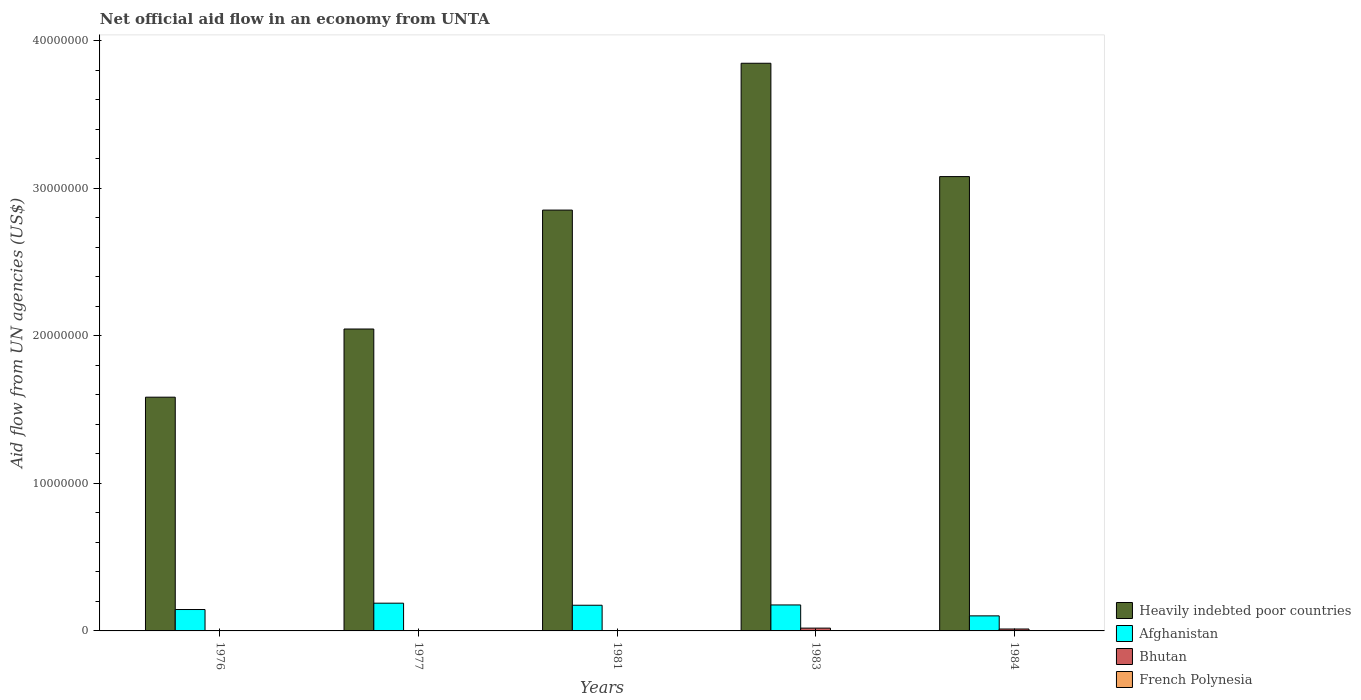How many different coloured bars are there?
Offer a terse response. 4. Are the number of bars per tick equal to the number of legend labels?
Ensure brevity in your answer.  Yes. How many bars are there on the 3rd tick from the left?
Make the answer very short. 4. What is the net official aid flow in Heavily indebted poor countries in 1984?
Your response must be concise. 3.08e+07. Across all years, what is the maximum net official aid flow in Bhutan?
Your response must be concise. 1.90e+05. Across all years, what is the minimum net official aid flow in Heavily indebted poor countries?
Your answer should be very brief. 1.58e+07. In which year was the net official aid flow in Bhutan maximum?
Offer a terse response. 1983. In which year was the net official aid flow in French Polynesia minimum?
Your response must be concise. 1976. What is the total net official aid flow in Afghanistan in the graph?
Offer a very short reply. 7.85e+06. What is the difference between the net official aid flow in Heavily indebted poor countries in 1977 and that in 1984?
Offer a terse response. -1.03e+07. What is the difference between the net official aid flow in Heavily indebted poor countries in 1983 and the net official aid flow in French Polynesia in 1984?
Your response must be concise. 3.84e+07. What is the average net official aid flow in Heavily indebted poor countries per year?
Offer a terse response. 2.68e+07. In the year 1984, what is the difference between the net official aid flow in Afghanistan and net official aid flow in Heavily indebted poor countries?
Ensure brevity in your answer.  -2.98e+07. In how many years, is the net official aid flow in French Polynesia greater than 26000000 US$?
Provide a short and direct response. 0. Is the net official aid flow in Afghanistan in 1981 less than that in 1984?
Make the answer very short. No. What is the difference between the highest and the second highest net official aid flow in Bhutan?
Ensure brevity in your answer.  6.00e+04. In how many years, is the net official aid flow in Heavily indebted poor countries greater than the average net official aid flow in Heavily indebted poor countries taken over all years?
Provide a short and direct response. 3. Is it the case that in every year, the sum of the net official aid flow in Bhutan and net official aid flow in Afghanistan is greater than the sum of net official aid flow in French Polynesia and net official aid flow in Heavily indebted poor countries?
Provide a succinct answer. No. What does the 3rd bar from the left in 1981 represents?
Keep it short and to the point. Bhutan. What does the 4th bar from the right in 1981 represents?
Make the answer very short. Heavily indebted poor countries. Is it the case that in every year, the sum of the net official aid flow in Afghanistan and net official aid flow in Bhutan is greater than the net official aid flow in Heavily indebted poor countries?
Make the answer very short. No. How many years are there in the graph?
Your answer should be very brief. 5. Are the values on the major ticks of Y-axis written in scientific E-notation?
Provide a short and direct response. No. What is the title of the graph?
Offer a terse response. Net official aid flow in an economy from UNTA. What is the label or title of the X-axis?
Provide a succinct answer. Years. What is the label or title of the Y-axis?
Your answer should be compact. Aid flow from UN agencies (US$). What is the Aid flow from UN agencies (US$) of Heavily indebted poor countries in 1976?
Your answer should be compact. 1.58e+07. What is the Aid flow from UN agencies (US$) in Afghanistan in 1976?
Ensure brevity in your answer.  1.45e+06. What is the Aid flow from UN agencies (US$) in Bhutan in 1976?
Offer a terse response. 10000. What is the Aid flow from UN agencies (US$) in Heavily indebted poor countries in 1977?
Your response must be concise. 2.05e+07. What is the Aid flow from UN agencies (US$) of Afghanistan in 1977?
Make the answer very short. 1.88e+06. What is the Aid flow from UN agencies (US$) in Bhutan in 1977?
Your response must be concise. 2.00e+04. What is the Aid flow from UN agencies (US$) in Heavily indebted poor countries in 1981?
Ensure brevity in your answer.  2.85e+07. What is the Aid flow from UN agencies (US$) of Afghanistan in 1981?
Your answer should be very brief. 1.74e+06. What is the Aid flow from UN agencies (US$) in Heavily indebted poor countries in 1983?
Offer a terse response. 3.85e+07. What is the Aid flow from UN agencies (US$) of Afghanistan in 1983?
Give a very brief answer. 1.76e+06. What is the Aid flow from UN agencies (US$) in Heavily indebted poor countries in 1984?
Provide a succinct answer. 3.08e+07. What is the Aid flow from UN agencies (US$) in Afghanistan in 1984?
Keep it short and to the point. 1.02e+06. Across all years, what is the maximum Aid flow from UN agencies (US$) of Heavily indebted poor countries?
Provide a short and direct response. 3.85e+07. Across all years, what is the maximum Aid flow from UN agencies (US$) of Afghanistan?
Offer a terse response. 1.88e+06. Across all years, what is the maximum Aid flow from UN agencies (US$) of Bhutan?
Ensure brevity in your answer.  1.90e+05. Across all years, what is the maximum Aid flow from UN agencies (US$) of French Polynesia?
Your response must be concise. 2.00e+04. Across all years, what is the minimum Aid flow from UN agencies (US$) of Heavily indebted poor countries?
Keep it short and to the point. 1.58e+07. Across all years, what is the minimum Aid flow from UN agencies (US$) in Afghanistan?
Keep it short and to the point. 1.02e+06. What is the total Aid flow from UN agencies (US$) in Heavily indebted poor countries in the graph?
Your response must be concise. 1.34e+08. What is the total Aid flow from UN agencies (US$) in Afghanistan in the graph?
Offer a very short reply. 7.85e+06. What is the difference between the Aid flow from UN agencies (US$) of Heavily indebted poor countries in 1976 and that in 1977?
Your answer should be very brief. -4.62e+06. What is the difference between the Aid flow from UN agencies (US$) in Afghanistan in 1976 and that in 1977?
Ensure brevity in your answer.  -4.30e+05. What is the difference between the Aid flow from UN agencies (US$) of Bhutan in 1976 and that in 1977?
Your answer should be compact. -10000. What is the difference between the Aid flow from UN agencies (US$) of French Polynesia in 1976 and that in 1977?
Ensure brevity in your answer.  0. What is the difference between the Aid flow from UN agencies (US$) in Heavily indebted poor countries in 1976 and that in 1981?
Offer a terse response. -1.27e+07. What is the difference between the Aid flow from UN agencies (US$) in Afghanistan in 1976 and that in 1981?
Offer a terse response. -2.90e+05. What is the difference between the Aid flow from UN agencies (US$) of Heavily indebted poor countries in 1976 and that in 1983?
Your response must be concise. -2.26e+07. What is the difference between the Aid flow from UN agencies (US$) in Afghanistan in 1976 and that in 1983?
Keep it short and to the point. -3.10e+05. What is the difference between the Aid flow from UN agencies (US$) in Bhutan in 1976 and that in 1983?
Your answer should be very brief. -1.80e+05. What is the difference between the Aid flow from UN agencies (US$) of Heavily indebted poor countries in 1976 and that in 1984?
Make the answer very short. -1.50e+07. What is the difference between the Aid flow from UN agencies (US$) of Afghanistan in 1976 and that in 1984?
Your answer should be compact. 4.30e+05. What is the difference between the Aid flow from UN agencies (US$) of French Polynesia in 1976 and that in 1984?
Provide a short and direct response. -10000. What is the difference between the Aid flow from UN agencies (US$) in Heavily indebted poor countries in 1977 and that in 1981?
Provide a succinct answer. -8.06e+06. What is the difference between the Aid flow from UN agencies (US$) in Afghanistan in 1977 and that in 1981?
Offer a terse response. 1.40e+05. What is the difference between the Aid flow from UN agencies (US$) of Heavily indebted poor countries in 1977 and that in 1983?
Provide a succinct answer. -1.80e+07. What is the difference between the Aid flow from UN agencies (US$) in Heavily indebted poor countries in 1977 and that in 1984?
Make the answer very short. -1.03e+07. What is the difference between the Aid flow from UN agencies (US$) in Afghanistan in 1977 and that in 1984?
Your response must be concise. 8.60e+05. What is the difference between the Aid flow from UN agencies (US$) of Bhutan in 1977 and that in 1984?
Your answer should be very brief. -1.10e+05. What is the difference between the Aid flow from UN agencies (US$) in French Polynesia in 1977 and that in 1984?
Your answer should be compact. -10000. What is the difference between the Aid flow from UN agencies (US$) in Heavily indebted poor countries in 1981 and that in 1983?
Provide a short and direct response. -9.95e+06. What is the difference between the Aid flow from UN agencies (US$) in Afghanistan in 1981 and that in 1983?
Keep it short and to the point. -2.00e+04. What is the difference between the Aid flow from UN agencies (US$) of Bhutan in 1981 and that in 1983?
Give a very brief answer. -1.70e+05. What is the difference between the Aid flow from UN agencies (US$) in French Polynesia in 1981 and that in 1983?
Provide a short and direct response. 10000. What is the difference between the Aid flow from UN agencies (US$) in Heavily indebted poor countries in 1981 and that in 1984?
Provide a short and direct response. -2.27e+06. What is the difference between the Aid flow from UN agencies (US$) of Afghanistan in 1981 and that in 1984?
Offer a very short reply. 7.20e+05. What is the difference between the Aid flow from UN agencies (US$) in Heavily indebted poor countries in 1983 and that in 1984?
Give a very brief answer. 7.68e+06. What is the difference between the Aid flow from UN agencies (US$) in Afghanistan in 1983 and that in 1984?
Your answer should be compact. 7.40e+05. What is the difference between the Aid flow from UN agencies (US$) in Bhutan in 1983 and that in 1984?
Your response must be concise. 6.00e+04. What is the difference between the Aid flow from UN agencies (US$) of Heavily indebted poor countries in 1976 and the Aid flow from UN agencies (US$) of Afghanistan in 1977?
Ensure brevity in your answer.  1.40e+07. What is the difference between the Aid flow from UN agencies (US$) in Heavily indebted poor countries in 1976 and the Aid flow from UN agencies (US$) in Bhutan in 1977?
Your answer should be very brief. 1.58e+07. What is the difference between the Aid flow from UN agencies (US$) of Heavily indebted poor countries in 1976 and the Aid flow from UN agencies (US$) of French Polynesia in 1977?
Your answer should be compact. 1.58e+07. What is the difference between the Aid flow from UN agencies (US$) in Afghanistan in 1976 and the Aid flow from UN agencies (US$) in Bhutan in 1977?
Offer a very short reply. 1.43e+06. What is the difference between the Aid flow from UN agencies (US$) in Afghanistan in 1976 and the Aid flow from UN agencies (US$) in French Polynesia in 1977?
Provide a short and direct response. 1.44e+06. What is the difference between the Aid flow from UN agencies (US$) of Heavily indebted poor countries in 1976 and the Aid flow from UN agencies (US$) of Afghanistan in 1981?
Keep it short and to the point. 1.41e+07. What is the difference between the Aid flow from UN agencies (US$) in Heavily indebted poor countries in 1976 and the Aid flow from UN agencies (US$) in Bhutan in 1981?
Make the answer very short. 1.58e+07. What is the difference between the Aid flow from UN agencies (US$) of Heavily indebted poor countries in 1976 and the Aid flow from UN agencies (US$) of French Polynesia in 1981?
Ensure brevity in your answer.  1.58e+07. What is the difference between the Aid flow from UN agencies (US$) of Afghanistan in 1976 and the Aid flow from UN agencies (US$) of Bhutan in 1981?
Your answer should be very brief. 1.43e+06. What is the difference between the Aid flow from UN agencies (US$) of Afghanistan in 1976 and the Aid flow from UN agencies (US$) of French Polynesia in 1981?
Keep it short and to the point. 1.43e+06. What is the difference between the Aid flow from UN agencies (US$) of Bhutan in 1976 and the Aid flow from UN agencies (US$) of French Polynesia in 1981?
Ensure brevity in your answer.  -10000. What is the difference between the Aid flow from UN agencies (US$) of Heavily indebted poor countries in 1976 and the Aid flow from UN agencies (US$) of Afghanistan in 1983?
Your answer should be compact. 1.41e+07. What is the difference between the Aid flow from UN agencies (US$) in Heavily indebted poor countries in 1976 and the Aid flow from UN agencies (US$) in Bhutan in 1983?
Give a very brief answer. 1.56e+07. What is the difference between the Aid flow from UN agencies (US$) in Heavily indebted poor countries in 1976 and the Aid flow from UN agencies (US$) in French Polynesia in 1983?
Your answer should be very brief. 1.58e+07. What is the difference between the Aid flow from UN agencies (US$) of Afghanistan in 1976 and the Aid flow from UN agencies (US$) of Bhutan in 1983?
Offer a very short reply. 1.26e+06. What is the difference between the Aid flow from UN agencies (US$) of Afghanistan in 1976 and the Aid flow from UN agencies (US$) of French Polynesia in 1983?
Ensure brevity in your answer.  1.44e+06. What is the difference between the Aid flow from UN agencies (US$) in Bhutan in 1976 and the Aid flow from UN agencies (US$) in French Polynesia in 1983?
Provide a succinct answer. 0. What is the difference between the Aid flow from UN agencies (US$) of Heavily indebted poor countries in 1976 and the Aid flow from UN agencies (US$) of Afghanistan in 1984?
Your answer should be compact. 1.48e+07. What is the difference between the Aid flow from UN agencies (US$) of Heavily indebted poor countries in 1976 and the Aid flow from UN agencies (US$) of Bhutan in 1984?
Provide a short and direct response. 1.57e+07. What is the difference between the Aid flow from UN agencies (US$) of Heavily indebted poor countries in 1976 and the Aid flow from UN agencies (US$) of French Polynesia in 1984?
Provide a succinct answer. 1.58e+07. What is the difference between the Aid flow from UN agencies (US$) of Afghanistan in 1976 and the Aid flow from UN agencies (US$) of Bhutan in 1984?
Make the answer very short. 1.32e+06. What is the difference between the Aid flow from UN agencies (US$) of Afghanistan in 1976 and the Aid flow from UN agencies (US$) of French Polynesia in 1984?
Your answer should be compact. 1.43e+06. What is the difference between the Aid flow from UN agencies (US$) of Heavily indebted poor countries in 1977 and the Aid flow from UN agencies (US$) of Afghanistan in 1981?
Make the answer very short. 1.87e+07. What is the difference between the Aid flow from UN agencies (US$) of Heavily indebted poor countries in 1977 and the Aid flow from UN agencies (US$) of Bhutan in 1981?
Your answer should be very brief. 2.04e+07. What is the difference between the Aid flow from UN agencies (US$) of Heavily indebted poor countries in 1977 and the Aid flow from UN agencies (US$) of French Polynesia in 1981?
Give a very brief answer. 2.04e+07. What is the difference between the Aid flow from UN agencies (US$) of Afghanistan in 1977 and the Aid flow from UN agencies (US$) of Bhutan in 1981?
Your answer should be compact. 1.86e+06. What is the difference between the Aid flow from UN agencies (US$) in Afghanistan in 1977 and the Aid flow from UN agencies (US$) in French Polynesia in 1981?
Make the answer very short. 1.86e+06. What is the difference between the Aid flow from UN agencies (US$) in Heavily indebted poor countries in 1977 and the Aid flow from UN agencies (US$) in Afghanistan in 1983?
Offer a terse response. 1.87e+07. What is the difference between the Aid flow from UN agencies (US$) of Heavily indebted poor countries in 1977 and the Aid flow from UN agencies (US$) of Bhutan in 1983?
Give a very brief answer. 2.03e+07. What is the difference between the Aid flow from UN agencies (US$) of Heavily indebted poor countries in 1977 and the Aid flow from UN agencies (US$) of French Polynesia in 1983?
Ensure brevity in your answer.  2.04e+07. What is the difference between the Aid flow from UN agencies (US$) of Afghanistan in 1977 and the Aid flow from UN agencies (US$) of Bhutan in 1983?
Provide a succinct answer. 1.69e+06. What is the difference between the Aid flow from UN agencies (US$) in Afghanistan in 1977 and the Aid flow from UN agencies (US$) in French Polynesia in 1983?
Give a very brief answer. 1.87e+06. What is the difference between the Aid flow from UN agencies (US$) in Bhutan in 1977 and the Aid flow from UN agencies (US$) in French Polynesia in 1983?
Your answer should be compact. 10000. What is the difference between the Aid flow from UN agencies (US$) of Heavily indebted poor countries in 1977 and the Aid flow from UN agencies (US$) of Afghanistan in 1984?
Make the answer very short. 1.94e+07. What is the difference between the Aid flow from UN agencies (US$) in Heavily indebted poor countries in 1977 and the Aid flow from UN agencies (US$) in Bhutan in 1984?
Ensure brevity in your answer.  2.03e+07. What is the difference between the Aid flow from UN agencies (US$) of Heavily indebted poor countries in 1977 and the Aid flow from UN agencies (US$) of French Polynesia in 1984?
Your answer should be very brief. 2.04e+07. What is the difference between the Aid flow from UN agencies (US$) in Afghanistan in 1977 and the Aid flow from UN agencies (US$) in Bhutan in 1984?
Your response must be concise. 1.75e+06. What is the difference between the Aid flow from UN agencies (US$) in Afghanistan in 1977 and the Aid flow from UN agencies (US$) in French Polynesia in 1984?
Offer a very short reply. 1.86e+06. What is the difference between the Aid flow from UN agencies (US$) of Heavily indebted poor countries in 1981 and the Aid flow from UN agencies (US$) of Afghanistan in 1983?
Ensure brevity in your answer.  2.68e+07. What is the difference between the Aid flow from UN agencies (US$) in Heavily indebted poor countries in 1981 and the Aid flow from UN agencies (US$) in Bhutan in 1983?
Offer a terse response. 2.83e+07. What is the difference between the Aid flow from UN agencies (US$) of Heavily indebted poor countries in 1981 and the Aid flow from UN agencies (US$) of French Polynesia in 1983?
Ensure brevity in your answer.  2.85e+07. What is the difference between the Aid flow from UN agencies (US$) of Afghanistan in 1981 and the Aid flow from UN agencies (US$) of Bhutan in 1983?
Give a very brief answer. 1.55e+06. What is the difference between the Aid flow from UN agencies (US$) of Afghanistan in 1981 and the Aid flow from UN agencies (US$) of French Polynesia in 1983?
Provide a succinct answer. 1.73e+06. What is the difference between the Aid flow from UN agencies (US$) of Bhutan in 1981 and the Aid flow from UN agencies (US$) of French Polynesia in 1983?
Your answer should be compact. 10000. What is the difference between the Aid flow from UN agencies (US$) in Heavily indebted poor countries in 1981 and the Aid flow from UN agencies (US$) in Afghanistan in 1984?
Ensure brevity in your answer.  2.75e+07. What is the difference between the Aid flow from UN agencies (US$) in Heavily indebted poor countries in 1981 and the Aid flow from UN agencies (US$) in Bhutan in 1984?
Keep it short and to the point. 2.84e+07. What is the difference between the Aid flow from UN agencies (US$) of Heavily indebted poor countries in 1981 and the Aid flow from UN agencies (US$) of French Polynesia in 1984?
Keep it short and to the point. 2.85e+07. What is the difference between the Aid flow from UN agencies (US$) in Afghanistan in 1981 and the Aid flow from UN agencies (US$) in Bhutan in 1984?
Keep it short and to the point. 1.61e+06. What is the difference between the Aid flow from UN agencies (US$) in Afghanistan in 1981 and the Aid flow from UN agencies (US$) in French Polynesia in 1984?
Provide a succinct answer. 1.72e+06. What is the difference between the Aid flow from UN agencies (US$) in Bhutan in 1981 and the Aid flow from UN agencies (US$) in French Polynesia in 1984?
Ensure brevity in your answer.  0. What is the difference between the Aid flow from UN agencies (US$) of Heavily indebted poor countries in 1983 and the Aid flow from UN agencies (US$) of Afghanistan in 1984?
Ensure brevity in your answer.  3.74e+07. What is the difference between the Aid flow from UN agencies (US$) of Heavily indebted poor countries in 1983 and the Aid flow from UN agencies (US$) of Bhutan in 1984?
Make the answer very short. 3.83e+07. What is the difference between the Aid flow from UN agencies (US$) of Heavily indebted poor countries in 1983 and the Aid flow from UN agencies (US$) of French Polynesia in 1984?
Offer a terse response. 3.84e+07. What is the difference between the Aid flow from UN agencies (US$) of Afghanistan in 1983 and the Aid flow from UN agencies (US$) of Bhutan in 1984?
Your response must be concise. 1.63e+06. What is the difference between the Aid flow from UN agencies (US$) in Afghanistan in 1983 and the Aid flow from UN agencies (US$) in French Polynesia in 1984?
Make the answer very short. 1.74e+06. What is the average Aid flow from UN agencies (US$) in Heavily indebted poor countries per year?
Keep it short and to the point. 2.68e+07. What is the average Aid flow from UN agencies (US$) of Afghanistan per year?
Keep it short and to the point. 1.57e+06. What is the average Aid flow from UN agencies (US$) in Bhutan per year?
Offer a terse response. 7.40e+04. What is the average Aid flow from UN agencies (US$) of French Polynesia per year?
Provide a short and direct response. 1.40e+04. In the year 1976, what is the difference between the Aid flow from UN agencies (US$) of Heavily indebted poor countries and Aid flow from UN agencies (US$) of Afghanistan?
Ensure brevity in your answer.  1.44e+07. In the year 1976, what is the difference between the Aid flow from UN agencies (US$) in Heavily indebted poor countries and Aid flow from UN agencies (US$) in Bhutan?
Give a very brief answer. 1.58e+07. In the year 1976, what is the difference between the Aid flow from UN agencies (US$) in Heavily indebted poor countries and Aid flow from UN agencies (US$) in French Polynesia?
Give a very brief answer. 1.58e+07. In the year 1976, what is the difference between the Aid flow from UN agencies (US$) of Afghanistan and Aid flow from UN agencies (US$) of Bhutan?
Ensure brevity in your answer.  1.44e+06. In the year 1976, what is the difference between the Aid flow from UN agencies (US$) in Afghanistan and Aid flow from UN agencies (US$) in French Polynesia?
Your answer should be very brief. 1.44e+06. In the year 1977, what is the difference between the Aid flow from UN agencies (US$) of Heavily indebted poor countries and Aid flow from UN agencies (US$) of Afghanistan?
Your answer should be very brief. 1.86e+07. In the year 1977, what is the difference between the Aid flow from UN agencies (US$) of Heavily indebted poor countries and Aid flow from UN agencies (US$) of Bhutan?
Provide a succinct answer. 2.04e+07. In the year 1977, what is the difference between the Aid flow from UN agencies (US$) in Heavily indebted poor countries and Aid flow from UN agencies (US$) in French Polynesia?
Your answer should be very brief. 2.04e+07. In the year 1977, what is the difference between the Aid flow from UN agencies (US$) of Afghanistan and Aid flow from UN agencies (US$) of Bhutan?
Your response must be concise. 1.86e+06. In the year 1977, what is the difference between the Aid flow from UN agencies (US$) of Afghanistan and Aid flow from UN agencies (US$) of French Polynesia?
Make the answer very short. 1.87e+06. In the year 1977, what is the difference between the Aid flow from UN agencies (US$) of Bhutan and Aid flow from UN agencies (US$) of French Polynesia?
Offer a very short reply. 10000. In the year 1981, what is the difference between the Aid flow from UN agencies (US$) of Heavily indebted poor countries and Aid flow from UN agencies (US$) of Afghanistan?
Provide a succinct answer. 2.68e+07. In the year 1981, what is the difference between the Aid flow from UN agencies (US$) of Heavily indebted poor countries and Aid flow from UN agencies (US$) of Bhutan?
Your answer should be very brief. 2.85e+07. In the year 1981, what is the difference between the Aid flow from UN agencies (US$) in Heavily indebted poor countries and Aid flow from UN agencies (US$) in French Polynesia?
Give a very brief answer. 2.85e+07. In the year 1981, what is the difference between the Aid flow from UN agencies (US$) in Afghanistan and Aid flow from UN agencies (US$) in Bhutan?
Make the answer very short. 1.72e+06. In the year 1981, what is the difference between the Aid flow from UN agencies (US$) of Afghanistan and Aid flow from UN agencies (US$) of French Polynesia?
Offer a very short reply. 1.72e+06. In the year 1983, what is the difference between the Aid flow from UN agencies (US$) in Heavily indebted poor countries and Aid flow from UN agencies (US$) in Afghanistan?
Give a very brief answer. 3.67e+07. In the year 1983, what is the difference between the Aid flow from UN agencies (US$) of Heavily indebted poor countries and Aid flow from UN agencies (US$) of Bhutan?
Ensure brevity in your answer.  3.83e+07. In the year 1983, what is the difference between the Aid flow from UN agencies (US$) of Heavily indebted poor countries and Aid flow from UN agencies (US$) of French Polynesia?
Give a very brief answer. 3.85e+07. In the year 1983, what is the difference between the Aid flow from UN agencies (US$) in Afghanistan and Aid flow from UN agencies (US$) in Bhutan?
Provide a succinct answer. 1.57e+06. In the year 1983, what is the difference between the Aid flow from UN agencies (US$) of Afghanistan and Aid flow from UN agencies (US$) of French Polynesia?
Your answer should be compact. 1.75e+06. In the year 1984, what is the difference between the Aid flow from UN agencies (US$) in Heavily indebted poor countries and Aid flow from UN agencies (US$) in Afghanistan?
Your response must be concise. 2.98e+07. In the year 1984, what is the difference between the Aid flow from UN agencies (US$) in Heavily indebted poor countries and Aid flow from UN agencies (US$) in Bhutan?
Keep it short and to the point. 3.07e+07. In the year 1984, what is the difference between the Aid flow from UN agencies (US$) in Heavily indebted poor countries and Aid flow from UN agencies (US$) in French Polynesia?
Your answer should be very brief. 3.08e+07. In the year 1984, what is the difference between the Aid flow from UN agencies (US$) in Afghanistan and Aid flow from UN agencies (US$) in Bhutan?
Ensure brevity in your answer.  8.90e+05. In the year 1984, what is the difference between the Aid flow from UN agencies (US$) in Bhutan and Aid flow from UN agencies (US$) in French Polynesia?
Your response must be concise. 1.10e+05. What is the ratio of the Aid flow from UN agencies (US$) in Heavily indebted poor countries in 1976 to that in 1977?
Your answer should be very brief. 0.77. What is the ratio of the Aid flow from UN agencies (US$) of Afghanistan in 1976 to that in 1977?
Make the answer very short. 0.77. What is the ratio of the Aid flow from UN agencies (US$) in French Polynesia in 1976 to that in 1977?
Your response must be concise. 1. What is the ratio of the Aid flow from UN agencies (US$) in Heavily indebted poor countries in 1976 to that in 1981?
Give a very brief answer. 0.56. What is the ratio of the Aid flow from UN agencies (US$) of Bhutan in 1976 to that in 1981?
Provide a succinct answer. 0.5. What is the ratio of the Aid flow from UN agencies (US$) of Heavily indebted poor countries in 1976 to that in 1983?
Give a very brief answer. 0.41. What is the ratio of the Aid flow from UN agencies (US$) of Afghanistan in 1976 to that in 1983?
Provide a succinct answer. 0.82. What is the ratio of the Aid flow from UN agencies (US$) of Bhutan in 1976 to that in 1983?
Make the answer very short. 0.05. What is the ratio of the Aid flow from UN agencies (US$) of Heavily indebted poor countries in 1976 to that in 1984?
Offer a terse response. 0.51. What is the ratio of the Aid flow from UN agencies (US$) in Afghanistan in 1976 to that in 1984?
Give a very brief answer. 1.42. What is the ratio of the Aid flow from UN agencies (US$) of Bhutan in 1976 to that in 1984?
Ensure brevity in your answer.  0.08. What is the ratio of the Aid flow from UN agencies (US$) of Heavily indebted poor countries in 1977 to that in 1981?
Provide a succinct answer. 0.72. What is the ratio of the Aid flow from UN agencies (US$) of Afghanistan in 1977 to that in 1981?
Provide a succinct answer. 1.08. What is the ratio of the Aid flow from UN agencies (US$) of French Polynesia in 1977 to that in 1981?
Ensure brevity in your answer.  0.5. What is the ratio of the Aid flow from UN agencies (US$) of Heavily indebted poor countries in 1977 to that in 1983?
Provide a succinct answer. 0.53. What is the ratio of the Aid flow from UN agencies (US$) in Afghanistan in 1977 to that in 1983?
Keep it short and to the point. 1.07. What is the ratio of the Aid flow from UN agencies (US$) in Bhutan in 1977 to that in 1983?
Offer a terse response. 0.11. What is the ratio of the Aid flow from UN agencies (US$) of Heavily indebted poor countries in 1977 to that in 1984?
Ensure brevity in your answer.  0.66. What is the ratio of the Aid flow from UN agencies (US$) of Afghanistan in 1977 to that in 1984?
Give a very brief answer. 1.84. What is the ratio of the Aid flow from UN agencies (US$) in Bhutan in 1977 to that in 1984?
Offer a terse response. 0.15. What is the ratio of the Aid flow from UN agencies (US$) of Heavily indebted poor countries in 1981 to that in 1983?
Give a very brief answer. 0.74. What is the ratio of the Aid flow from UN agencies (US$) of Bhutan in 1981 to that in 1983?
Provide a succinct answer. 0.11. What is the ratio of the Aid flow from UN agencies (US$) in French Polynesia in 1981 to that in 1983?
Provide a succinct answer. 2. What is the ratio of the Aid flow from UN agencies (US$) in Heavily indebted poor countries in 1981 to that in 1984?
Provide a short and direct response. 0.93. What is the ratio of the Aid flow from UN agencies (US$) of Afghanistan in 1981 to that in 1984?
Keep it short and to the point. 1.71. What is the ratio of the Aid flow from UN agencies (US$) of Bhutan in 1981 to that in 1984?
Provide a short and direct response. 0.15. What is the ratio of the Aid flow from UN agencies (US$) in French Polynesia in 1981 to that in 1984?
Offer a very short reply. 1. What is the ratio of the Aid flow from UN agencies (US$) in Heavily indebted poor countries in 1983 to that in 1984?
Ensure brevity in your answer.  1.25. What is the ratio of the Aid flow from UN agencies (US$) of Afghanistan in 1983 to that in 1984?
Offer a very short reply. 1.73. What is the ratio of the Aid flow from UN agencies (US$) of Bhutan in 1983 to that in 1984?
Provide a succinct answer. 1.46. What is the difference between the highest and the second highest Aid flow from UN agencies (US$) in Heavily indebted poor countries?
Make the answer very short. 7.68e+06. What is the difference between the highest and the second highest Aid flow from UN agencies (US$) of Afghanistan?
Your answer should be compact. 1.20e+05. What is the difference between the highest and the second highest Aid flow from UN agencies (US$) of French Polynesia?
Ensure brevity in your answer.  0. What is the difference between the highest and the lowest Aid flow from UN agencies (US$) of Heavily indebted poor countries?
Your answer should be very brief. 2.26e+07. What is the difference between the highest and the lowest Aid flow from UN agencies (US$) in Afghanistan?
Your answer should be very brief. 8.60e+05. What is the difference between the highest and the lowest Aid flow from UN agencies (US$) in Bhutan?
Keep it short and to the point. 1.80e+05. 